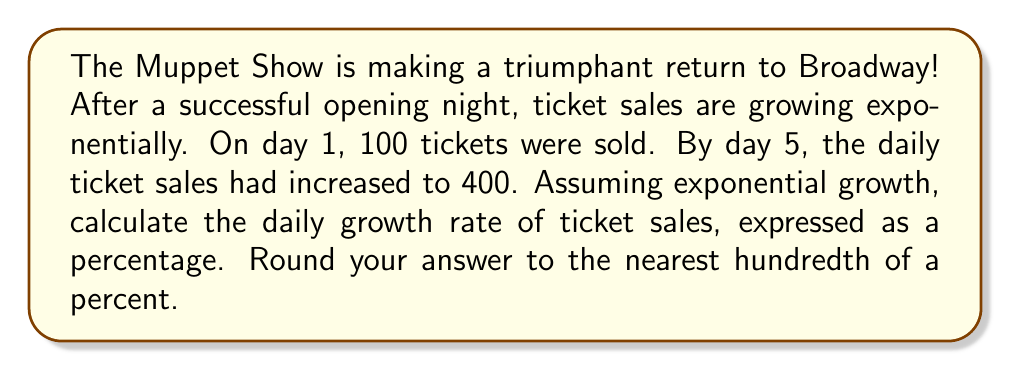What is the answer to this math problem? Let's approach this step-by-step using the exponential growth formula:

$$A = P(1 + r)^t$$

Where:
$A$ is the final amount
$P$ is the initial amount
$r$ is the daily growth rate (as a decimal)
$t$ is the time (in days)

1) We know:
   $P = 100$ (initial tickets sold on day 1)
   $A = 400$ (tickets sold on day 5)
   $t = 4$ (growth occurred over 4 days, from day 1 to day 5)

2) Plug these values into the formula:
   $$400 = 100(1 + r)^4$$

3) Divide both sides by 100:
   $$4 = (1 + r)^4$$

4) Take the fourth root of both sides:
   $$\sqrt[4]{4} = 1 + r$$

5) Solve for $r$:
   $$r = \sqrt[4]{4} - 1$$

6) Calculate the value:
   $$r \approx 1.4142 - 1 = 0.4142$$

7) Convert to a percentage:
   $$0.4142 \times 100 = 41.42\%$$

8) Round to the nearest hundredth of a percent:
   $$41.42\%$$
Answer: 41.42% 